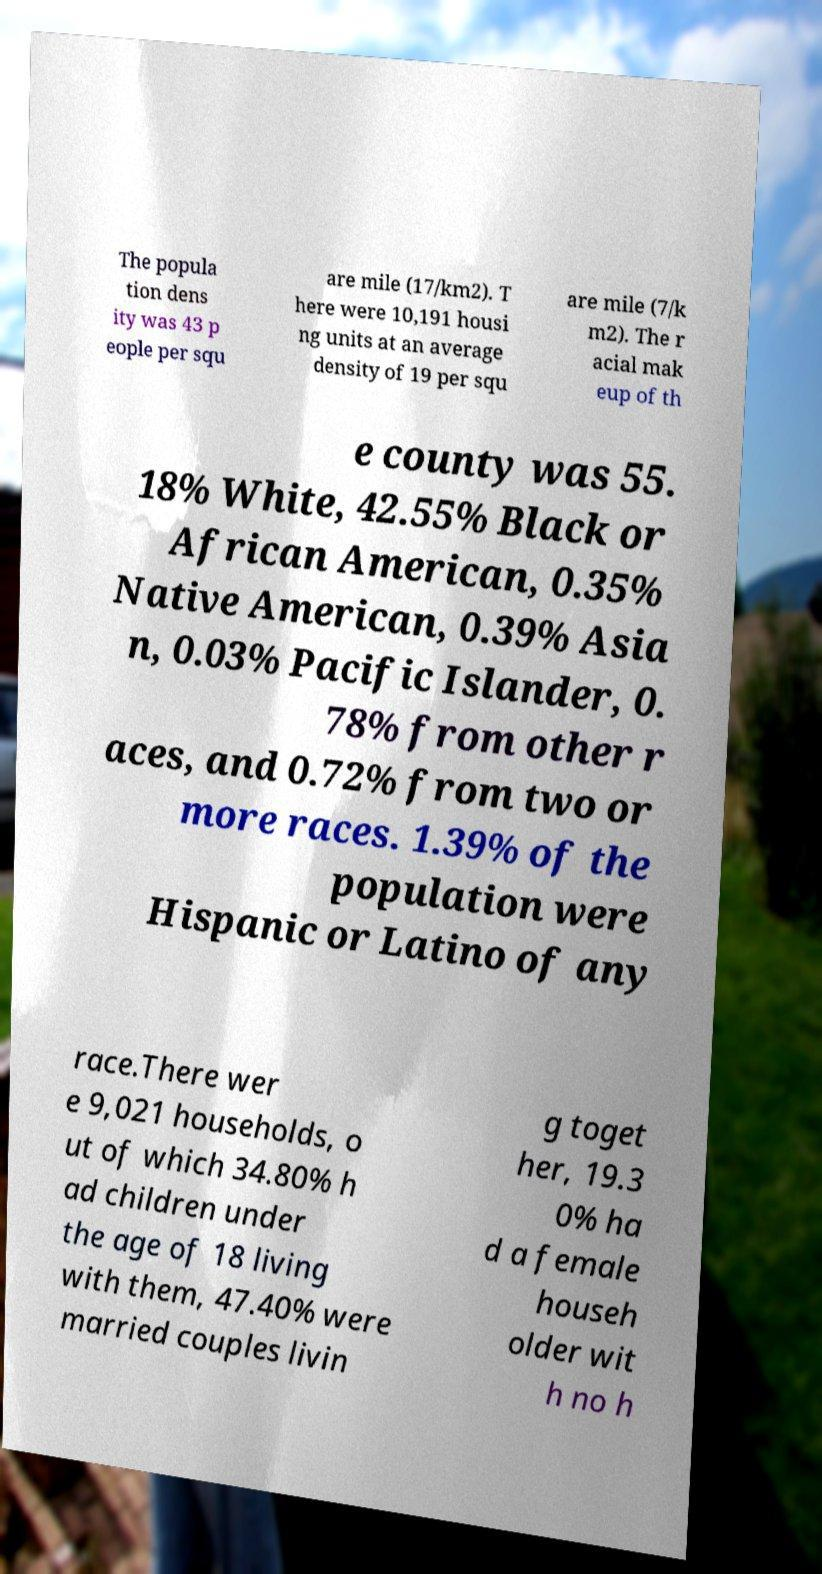Can you accurately transcribe the text from the provided image for me? The popula tion dens ity was 43 p eople per squ are mile (17/km2). T here were 10,191 housi ng units at an average density of 19 per squ are mile (7/k m2). The r acial mak eup of th e county was 55. 18% White, 42.55% Black or African American, 0.35% Native American, 0.39% Asia n, 0.03% Pacific Islander, 0. 78% from other r aces, and 0.72% from two or more races. 1.39% of the population were Hispanic or Latino of any race.There wer e 9,021 households, o ut of which 34.80% h ad children under the age of 18 living with them, 47.40% were married couples livin g toget her, 19.3 0% ha d a female househ older wit h no h 